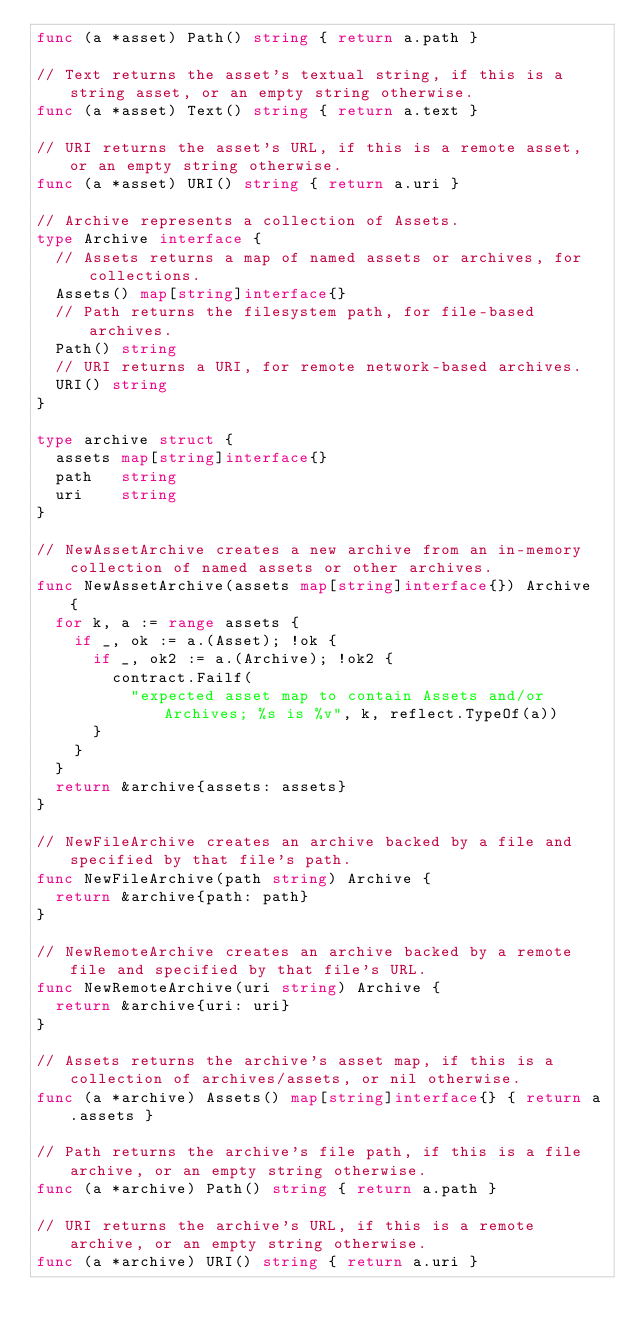Convert code to text. <code><loc_0><loc_0><loc_500><loc_500><_Go_>func (a *asset) Path() string { return a.path }

// Text returns the asset's textual string, if this is a string asset, or an empty string otherwise.
func (a *asset) Text() string { return a.text }

// URI returns the asset's URL, if this is a remote asset, or an empty string otherwise.
func (a *asset) URI() string { return a.uri }

// Archive represents a collection of Assets.
type Archive interface {
	// Assets returns a map of named assets or archives, for collections.
	Assets() map[string]interface{}
	// Path returns the filesystem path, for file-based archives.
	Path() string
	// URI returns a URI, for remote network-based archives.
	URI() string
}

type archive struct {
	assets map[string]interface{}
	path   string
	uri    string
}

// NewAssetArchive creates a new archive from an in-memory collection of named assets or other archives.
func NewAssetArchive(assets map[string]interface{}) Archive {
	for k, a := range assets {
		if _, ok := a.(Asset); !ok {
			if _, ok2 := a.(Archive); !ok2 {
				contract.Failf(
					"expected asset map to contain Assets and/or Archives; %s is %v", k, reflect.TypeOf(a))
			}
		}
	}
	return &archive{assets: assets}
}

// NewFileArchive creates an archive backed by a file and specified by that file's path.
func NewFileArchive(path string) Archive {
	return &archive{path: path}
}

// NewRemoteArchive creates an archive backed by a remote file and specified by that file's URL.
func NewRemoteArchive(uri string) Archive {
	return &archive{uri: uri}
}

// Assets returns the archive's asset map, if this is a collection of archives/assets, or nil otherwise.
func (a *archive) Assets() map[string]interface{} { return a.assets }

// Path returns the archive's file path, if this is a file archive, or an empty string otherwise.
func (a *archive) Path() string { return a.path }

// URI returns the archive's URL, if this is a remote archive, or an empty string otherwise.
func (a *archive) URI() string { return a.uri }
</code> 